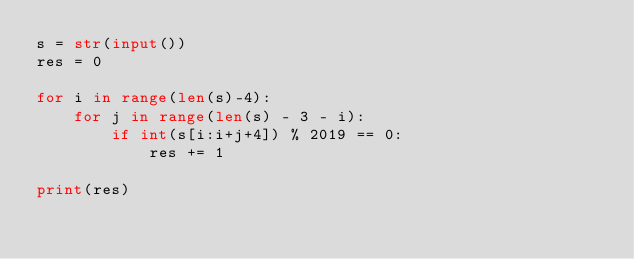Convert code to text. <code><loc_0><loc_0><loc_500><loc_500><_Python_>s = str(input())
res = 0

for i in range(len(s)-4):
    for j in range(len(s) - 3 - i):
        if int(s[i:i+j+4]) % 2019 == 0:
            res += 1

print(res)
        </code> 